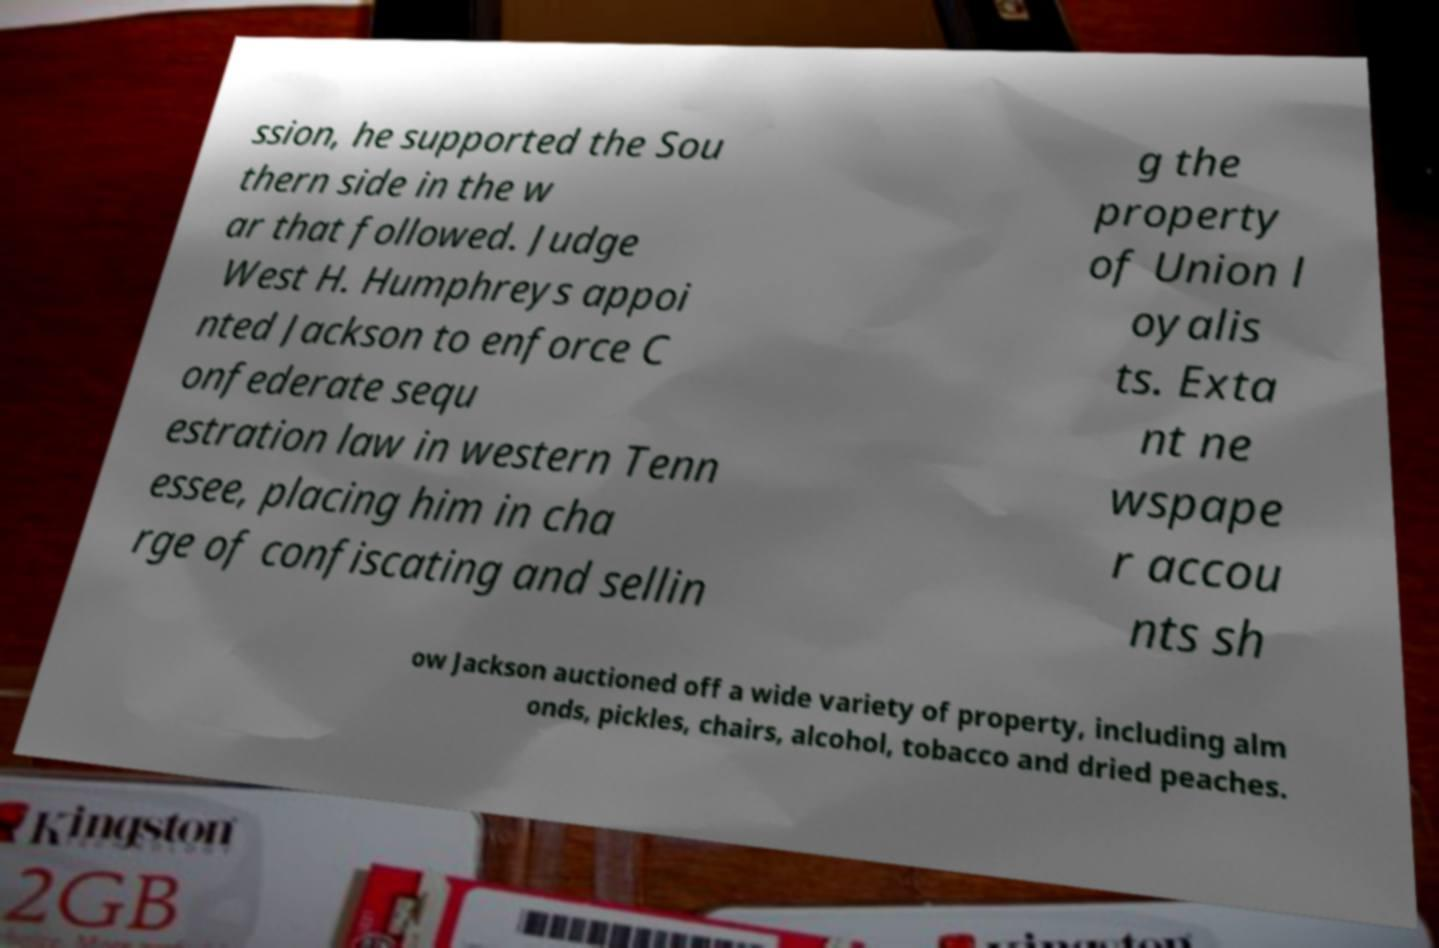For documentation purposes, I need the text within this image transcribed. Could you provide that? ssion, he supported the Sou thern side in the w ar that followed. Judge West H. Humphreys appoi nted Jackson to enforce C onfederate sequ estration law in western Tenn essee, placing him in cha rge of confiscating and sellin g the property of Union l oyalis ts. Exta nt ne wspape r accou nts sh ow Jackson auctioned off a wide variety of property, including alm onds, pickles, chairs, alcohol, tobacco and dried peaches. 